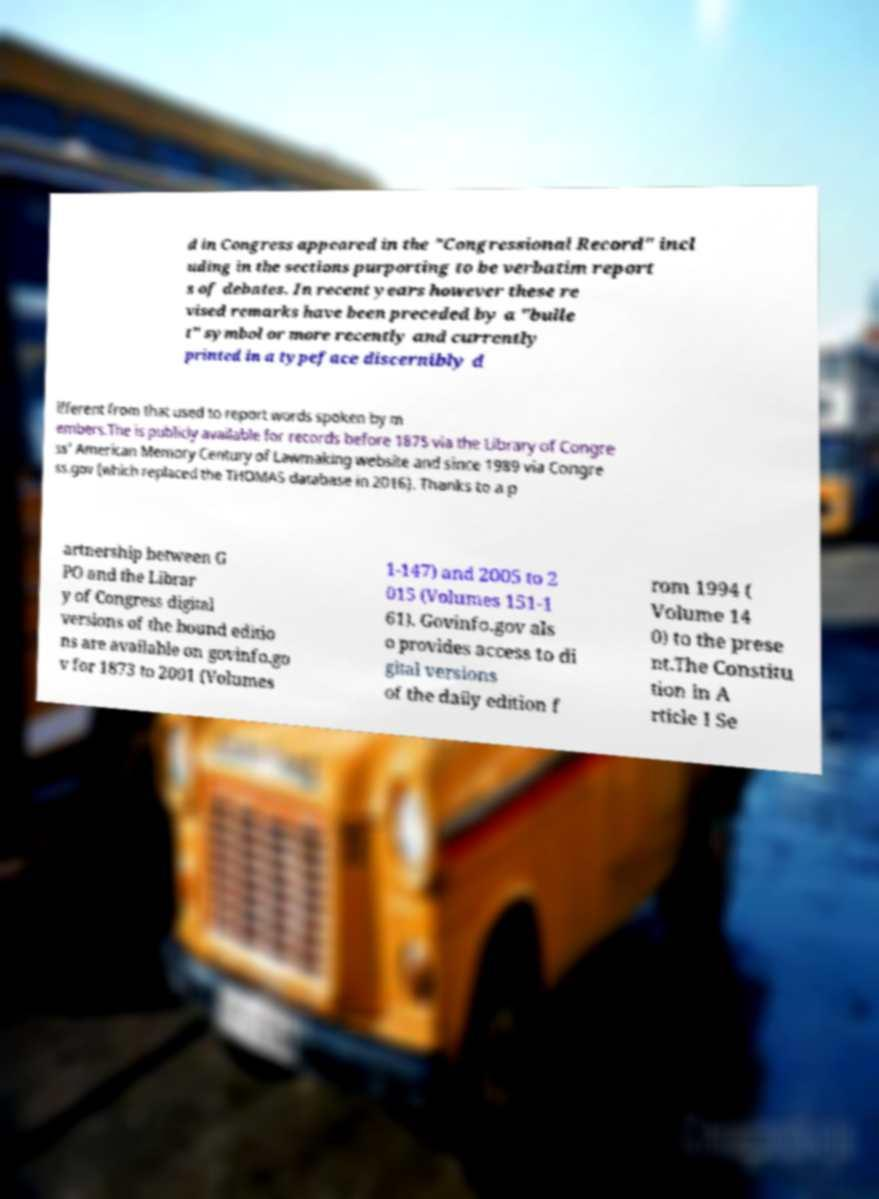What messages or text are displayed in this image? I need them in a readable, typed format. d in Congress appeared in the "Congressional Record" incl uding in the sections purporting to be verbatim report s of debates. In recent years however these re vised remarks have been preceded by a "bulle t" symbol or more recently and currently printed in a typeface discernibly d ifferent from that used to report words spoken by m embers.The is publicly available for records before 1875 via the Library of Congre ss' American Memory Century of Lawmaking website and since 1989 via Congre ss.gov (which replaced the THOMAS database in 2016). Thanks to a p artnership between G PO and the Librar y of Congress digital versions of the bound editio ns are available on govinfo.go v for 1873 to 2001 (Volumes 1-147) and 2005 to 2 015 (Volumes 151-1 61). Govinfo.gov als o provides access to di gital versions of the daily edition f rom 1994 ( Volume 14 0) to the prese nt.The Constitu tion in A rticle I Se 